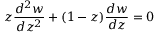<formula> <loc_0><loc_0><loc_500><loc_500>z { \frac { d ^ { 2 } w } { d z ^ { 2 } } } + ( 1 - z ) { \frac { d w } { d z } } = 0</formula> 